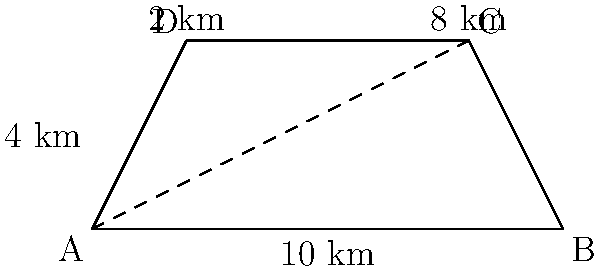As part of an environmental impact assessment for a proposed flood control project, you need to calculate the area of a trapezoidal flood zone. The zone is represented by the trapezoid ABCD in the diagram. If the parallel sides of the trapezoid are 10 km and 6 km long, and the height of the trapezoid is 4 km, what is the total area of the flood control zone in square kilometers? To calculate the area of a trapezoid, we use the formula:

$$A = \frac{1}{2}(b_1 + b_2)h$$

Where:
$A$ = Area of the trapezoid
$b_1$ = Length of one parallel side
$b_2$ = Length of the other parallel side
$h$ = Height of the trapezoid

Given:
$b_1 = 10$ km (bottom side AB)
$b_2 = 6$ km (top side DC, which is 8 km - 2 km)
$h = 4$ km (height)

Substituting these values into the formula:

$$A = \frac{1}{2}(10 + 6) \times 4$$
$$A = \frac{1}{2}(16) \times 4$$
$$A = 8 \times 4$$
$$A = 32$$

Therefore, the total area of the flood control zone is 32 square kilometers.
Answer: 32 sq km 